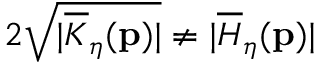<formula> <loc_0><loc_0><loc_500><loc_500>2 \sqrt { | \overline { K } _ { \eta } ( p ) | } \neq | \overline { H } _ { \eta } ( p ) |</formula> 